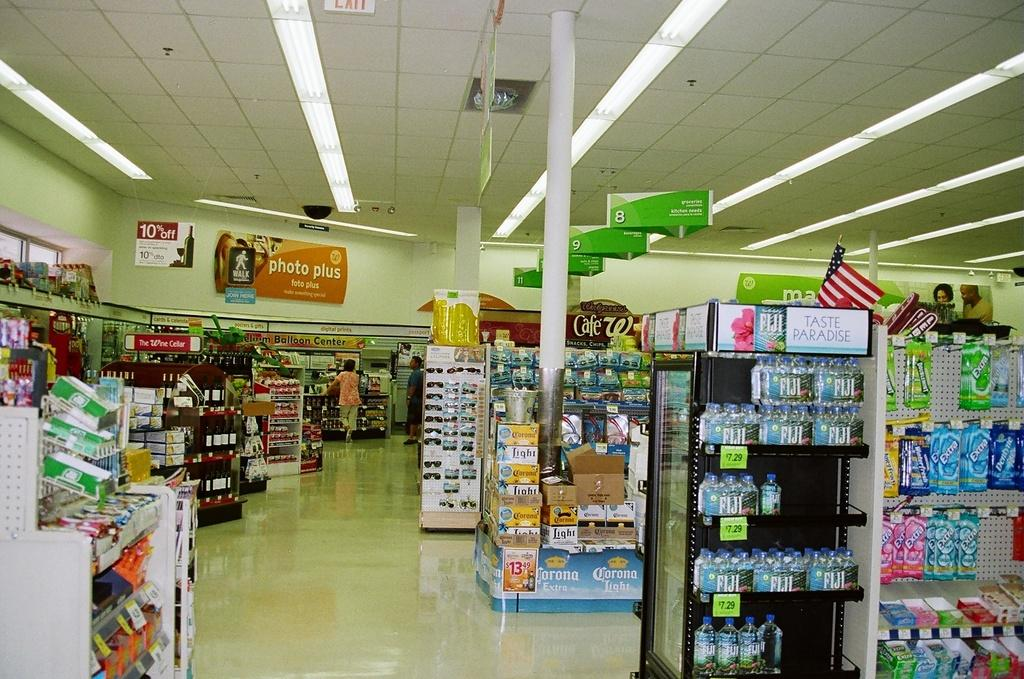<image>
Relay a brief, clear account of the picture shown. The inside of a grocery store which has a sign reading photo plus 